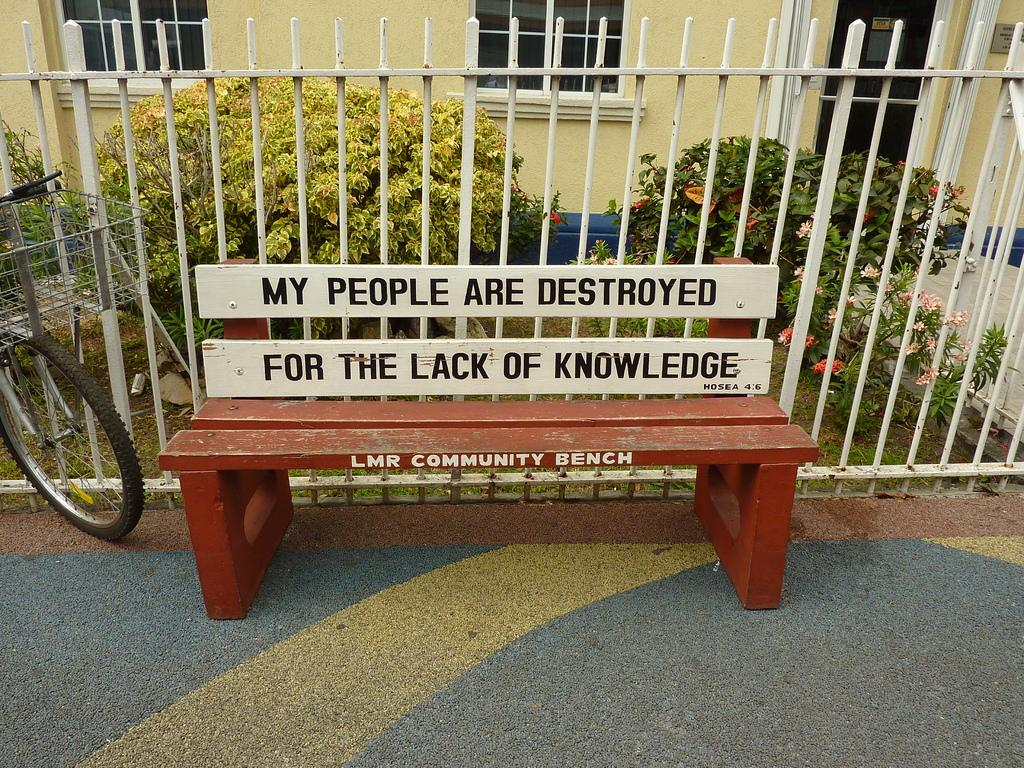What type of seating is visible in the image? There is a bench in the image. What is located behind the bench? There is fencing behind the bench. What can be seen in the background of the image? There are trees and a house in the background of the image. What mode of transportation is on the left side of the image? There is a bicycle on the left side of the image. What type of judge is sitting on the bench in the image? There is no judge present in the image; it only features a bench, fencing, trees, a house, and a bicycle. How many geese are visible in the image? There are no geese present in the image. 